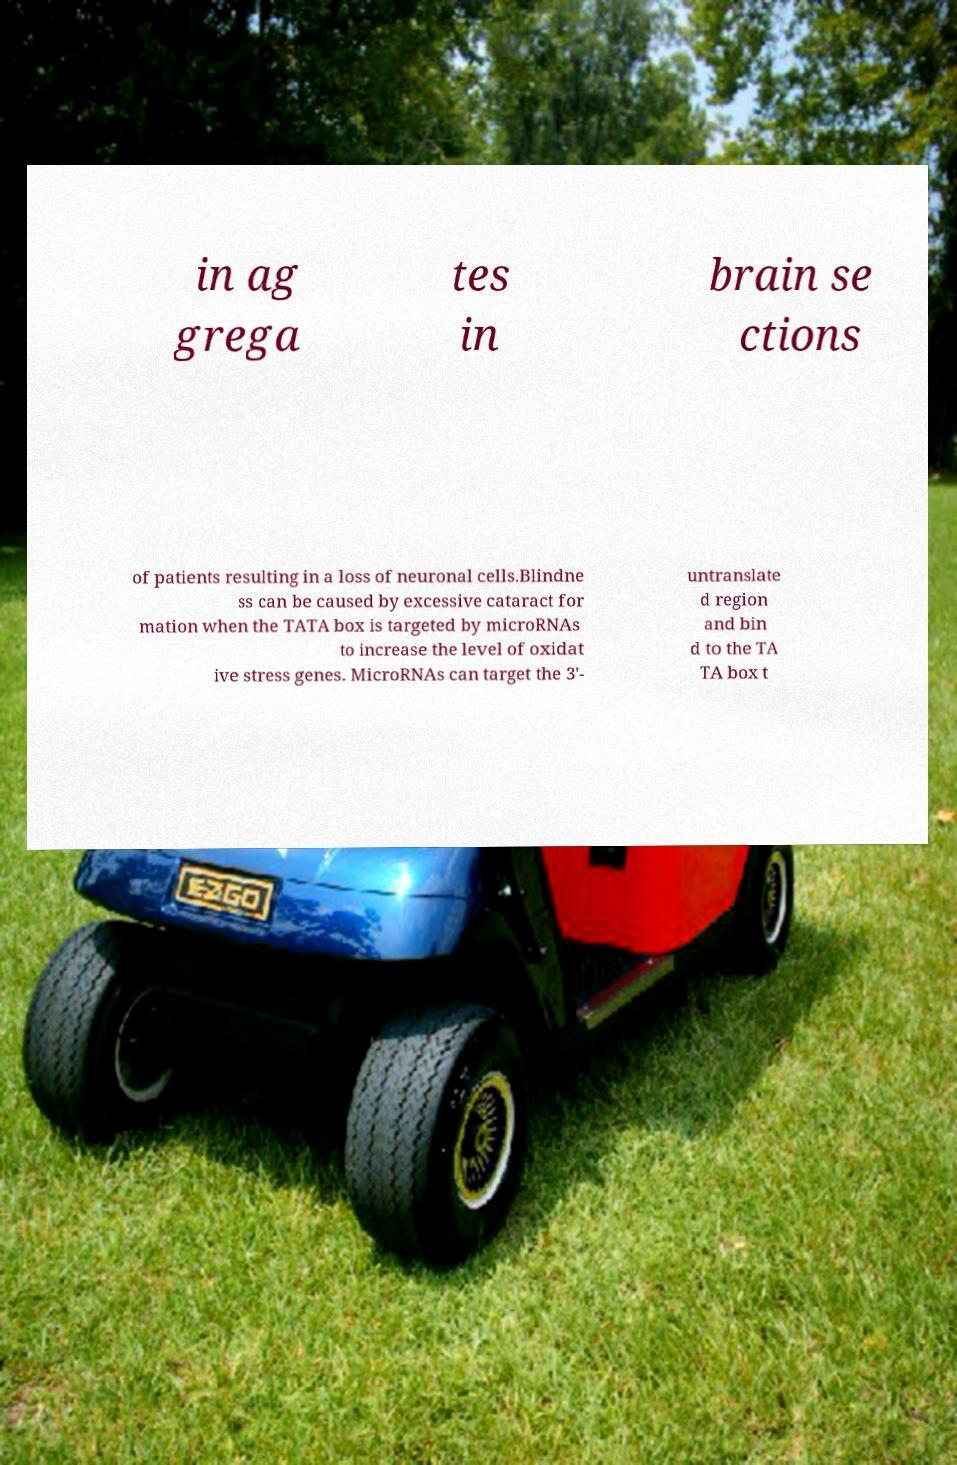What messages or text are displayed in this image? I need them in a readable, typed format. in ag grega tes in brain se ctions of patients resulting in a loss of neuronal cells.Blindne ss can be caused by excessive cataract for mation when the TATA box is targeted by microRNAs to increase the level of oxidat ive stress genes. MicroRNAs can target the 3'- untranslate d region and bin d to the TA TA box t 